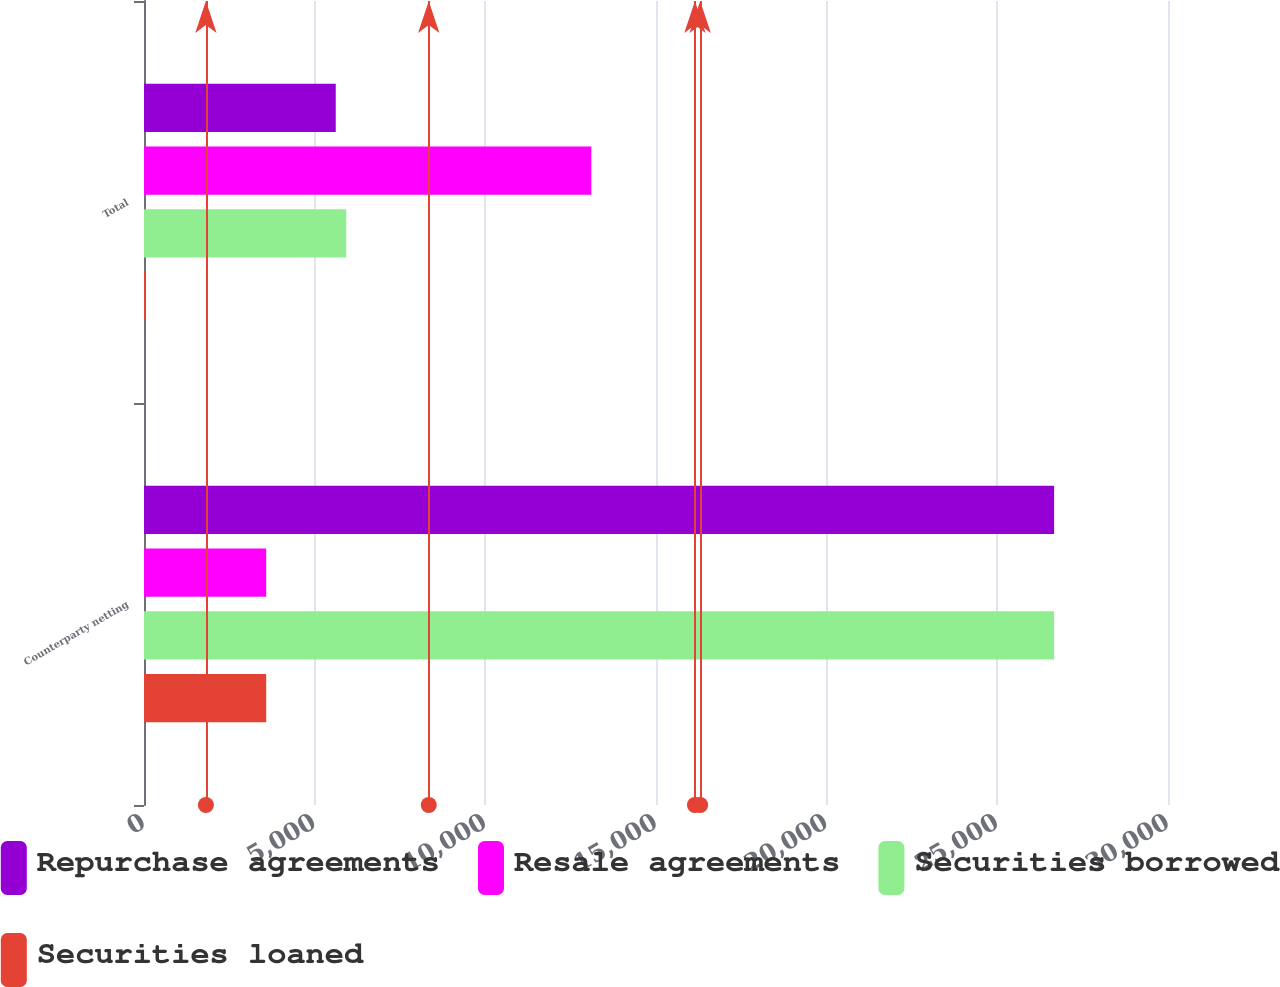<chart> <loc_0><loc_0><loc_500><loc_500><stacked_bar_chart><ecel><fcel>Counterparty netting<fcel>Total<nl><fcel>Repurchase agreements<fcel>26664<fcel>5618<nl><fcel>Resale agreements<fcel>3580<fcel>13105<nl><fcel>Securities borrowed<fcel>26664<fcel>5924<nl><fcel>Securities loaned<fcel>3580<fcel>47<nl></chart> 